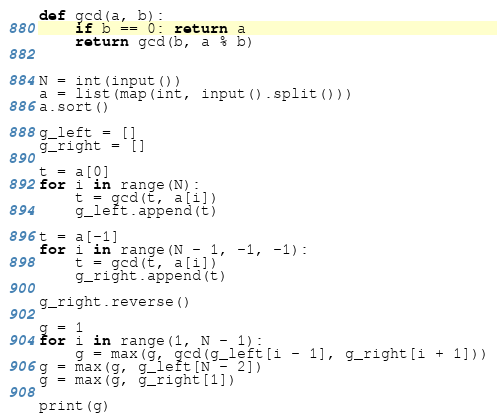<code> <loc_0><loc_0><loc_500><loc_500><_Python_>def gcd(a, b):
    if b == 0: return a
    return gcd(b, a % b)


N = int(input())
a = list(map(int, input().split()))
a.sort()

g_left = []
g_right = []

t = a[0]
for i in range(N):
    t = gcd(t, a[i])
    g_left.append(t)

t = a[-1]
for i in range(N - 1, -1, -1):
    t = gcd(t, a[i])
    g_right.append(t)

g_right.reverse()

g = 1
for i in range(1, N - 1):
    g = max(g, gcd(g_left[i - 1], g_right[i + 1]))
g = max(g, g_left[N - 2])
g = max(g, g_right[1])

print(g)
</code> 